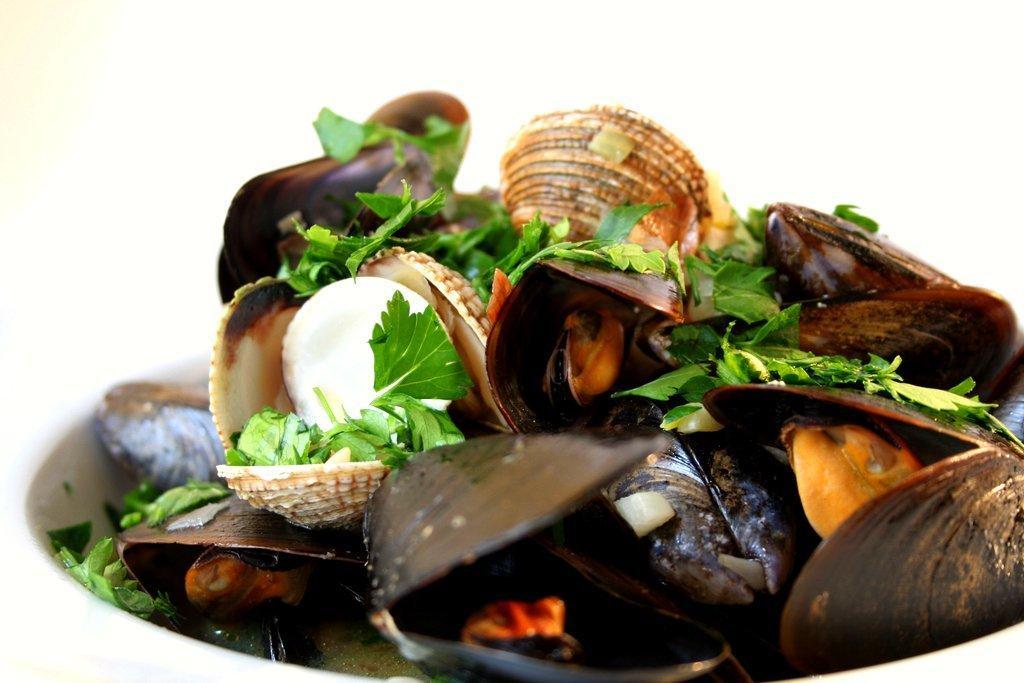How would you summarize this image in a sentence or two? In this picture i can see many shells in a bowl. On the shells i can see some mint and food item. 